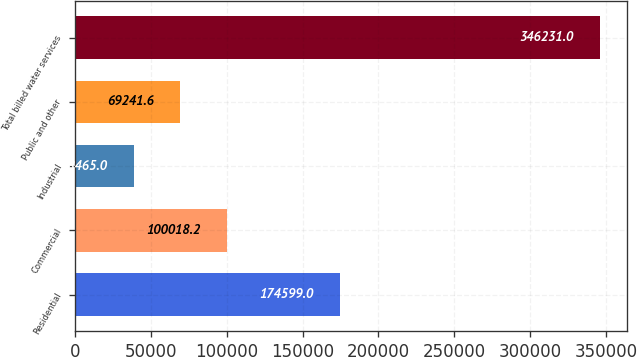<chart> <loc_0><loc_0><loc_500><loc_500><bar_chart><fcel>Residential<fcel>Commercial<fcel>Industrial<fcel>Public and other<fcel>Total billed water services<nl><fcel>174599<fcel>100018<fcel>38465<fcel>69241.6<fcel>346231<nl></chart> 